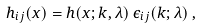Convert formula to latex. <formula><loc_0><loc_0><loc_500><loc_500>h _ { i j } ( x ) = h ( x ; { k } , \lambda ) \, \epsilon _ { i j } ( { k } ; \lambda ) \, ,</formula> 